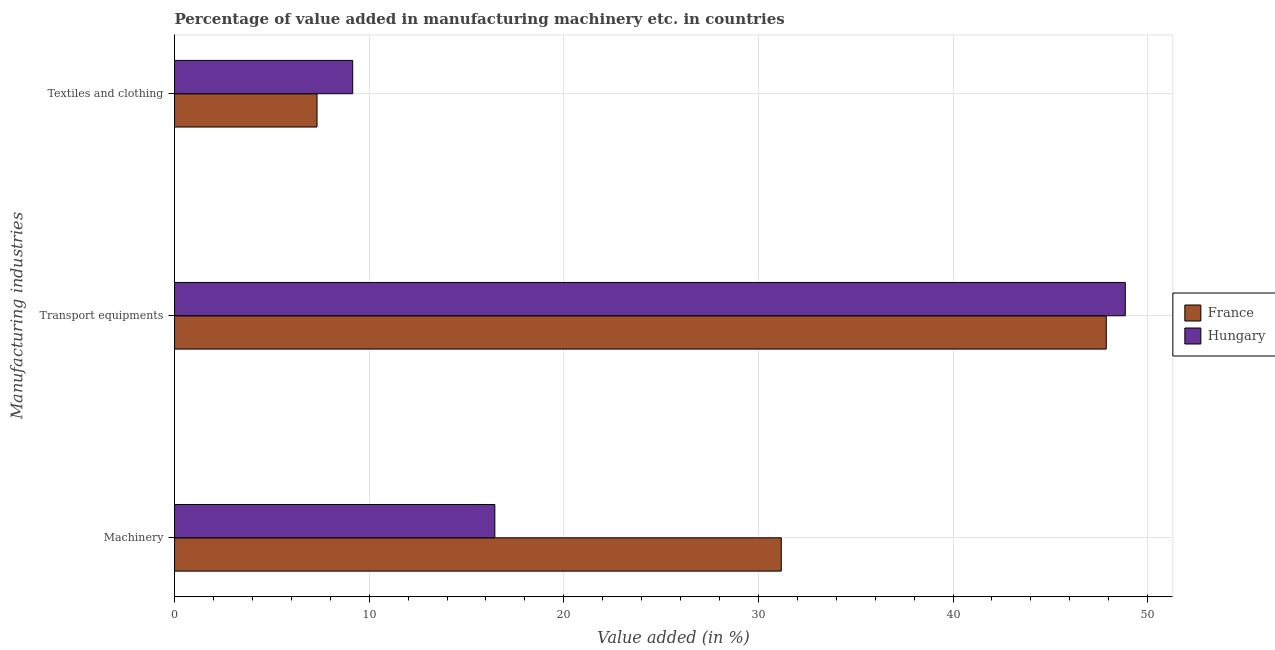How many groups of bars are there?
Keep it short and to the point. 3. Are the number of bars per tick equal to the number of legend labels?
Give a very brief answer. Yes. How many bars are there on the 1st tick from the bottom?
Your answer should be compact. 2. What is the label of the 2nd group of bars from the top?
Keep it short and to the point. Transport equipments. What is the value added in manufacturing transport equipments in France?
Your answer should be compact. 47.87. Across all countries, what is the maximum value added in manufacturing transport equipments?
Provide a succinct answer. 48.85. Across all countries, what is the minimum value added in manufacturing textile and clothing?
Your answer should be very brief. 7.32. In which country was the value added in manufacturing machinery maximum?
Offer a terse response. France. What is the total value added in manufacturing textile and clothing in the graph?
Offer a very short reply. 16.47. What is the difference between the value added in manufacturing machinery in Hungary and that in France?
Offer a very short reply. -14.72. What is the difference between the value added in manufacturing textile and clothing in Hungary and the value added in manufacturing machinery in France?
Provide a succinct answer. -22.02. What is the average value added in manufacturing machinery per country?
Your answer should be compact. 23.82. What is the difference between the value added in manufacturing machinery and value added in manufacturing transport equipments in Hungary?
Give a very brief answer. -32.39. What is the ratio of the value added in manufacturing transport equipments in Hungary to that in France?
Give a very brief answer. 1.02. Is the difference between the value added in manufacturing transport equipments in Hungary and France greater than the difference between the value added in manufacturing textile and clothing in Hungary and France?
Your answer should be very brief. No. What is the difference between the highest and the second highest value added in manufacturing machinery?
Your answer should be very brief. 14.72. What is the difference between the highest and the lowest value added in manufacturing machinery?
Make the answer very short. 14.72. In how many countries, is the value added in manufacturing machinery greater than the average value added in manufacturing machinery taken over all countries?
Your answer should be compact. 1. What does the 2nd bar from the bottom in Textiles and clothing represents?
Your answer should be very brief. Hungary. Are all the bars in the graph horizontal?
Your response must be concise. Yes. Does the graph contain grids?
Offer a very short reply. Yes. How many legend labels are there?
Offer a very short reply. 2. How are the legend labels stacked?
Give a very brief answer. Vertical. What is the title of the graph?
Offer a terse response. Percentage of value added in manufacturing machinery etc. in countries. What is the label or title of the X-axis?
Your answer should be compact. Value added (in %). What is the label or title of the Y-axis?
Provide a succinct answer. Manufacturing industries. What is the Value added (in %) in France in Machinery?
Provide a succinct answer. 31.17. What is the Value added (in %) in Hungary in Machinery?
Your answer should be compact. 16.46. What is the Value added (in %) of France in Transport equipments?
Your answer should be very brief. 47.87. What is the Value added (in %) in Hungary in Transport equipments?
Give a very brief answer. 48.85. What is the Value added (in %) of France in Textiles and clothing?
Your answer should be very brief. 7.32. What is the Value added (in %) of Hungary in Textiles and clothing?
Your response must be concise. 9.15. Across all Manufacturing industries, what is the maximum Value added (in %) of France?
Keep it short and to the point. 47.87. Across all Manufacturing industries, what is the maximum Value added (in %) of Hungary?
Provide a short and direct response. 48.85. Across all Manufacturing industries, what is the minimum Value added (in %) in France?
Your answer should be very brief. 7.32. Across all Manufacturing industries, what is the minimum Value added (in %) in Hungary?
Your response must be concise. 9.15. What is the total Value added (in %) in France in the graph?
Provide a short and direct response. 86.37. What is the total Value added (in %) in Hungary in the graph?
Your answer should be compact. 74.46. What is the difference between the Value added (in %) of France in Machinery and that in Transport equipments?
Your answer should be very brief. -16.7. What is the difference between the Value added (in %) in Hungary in Machinery and that in Transport equipments?
Offer a very short reply. -32.39. What is the difference between the Value added (in %) of France in Machinery and that in Textiles and clothing?
Make the answer very short. 23.85. What is the difference between the Value added (in %) in Hungary in Machinery and that in Textiles and clothing?
Make the answer very short. 7.3. What is the difference between the Value added (in %) in France in Transport equipments and that in Textiles and clothing?
Your answer should be very brief. 40.55. What is the difference between the Value added (in %) in Hungary in Transport equipments and that in Textiles and clothing?
Provide a succinct answer. 39.7. What is the difference between the Value added (in %) in France in Machinery and the Value added (in %) in Hungary in Transport equipments?
Provide a succinct answer. -17.68. What is the difference between the Value added (in %) of France in Machinery and the Value added (in %) of Hungary in Textiles and clothing?
Provide a succinct answer. 22.02. What is the difference between the Value added (in %) of France in Transport equipments and the Value added (in %) of Hungary in Textiles and clothing?
Offer a very short reply. 38.72. What is the average Value added (in %) of France per Manufacturing industries?
Your answer should be compact. 28.79. What is the average Value added (in %) in Hungary per Manufacturing industries?
Ensure brevity in your answer.  24.82. What is the difference between the Value added (in %) of France and Value added (in %) of Hungary in Machinery?
Offer a very short reply. 14.72. What is the difference between the Value added (in %) of France and Value added (in %) of Hungary in Transport equipments?
Your response must be concise. -0.98. What is the difference between the Value added (in %) in France and Value added (in %) in Hungary in Textiles and clothing?
Make the answer very short. -1.83. What is the ratio of the Value added (in %) in France in Machinery to that in Transport equipments?
Ensure brevity in your answer.  0.65. What is the ratio of the Value added (in %) in Hungary in Machinery to that in Transport equipments?
Offer a terse response. 0.34. What is the ratio of the Value added (in %) of France in Machinery to that in Textiles and clothing?
Give a very brief answer. 4.26. What is the ratio of the Value added (in %) of Hungary in Machinery to that in Textiles and clothing?
Provide a succinct answer. 1.8. What is the ratio of the Value added (in %) of France in Transport equipments to that in Textiles and clothing?
Provide a short and direct response. 6.54. What is the ratio of the Value added (in %) of Hungary in Transport equipments to that in Textiles and clothing?
Your response must be concise. 5.34. What is the difference between the highest and the second highest Value added (in %) in France?
Ensure brevity in your answer.  16.7. What is the difference between the highest and the second highest Value added (in %) in Hungary?
Offer a terse response. 32.39. What is the difference between the highest and the lowest Value added (in %) in France?
Your answer should be compact. 40.55. What is the difference between the highest and the lowest Value added (in %) in Hungary?
Your answer should be compact. 39.7. 